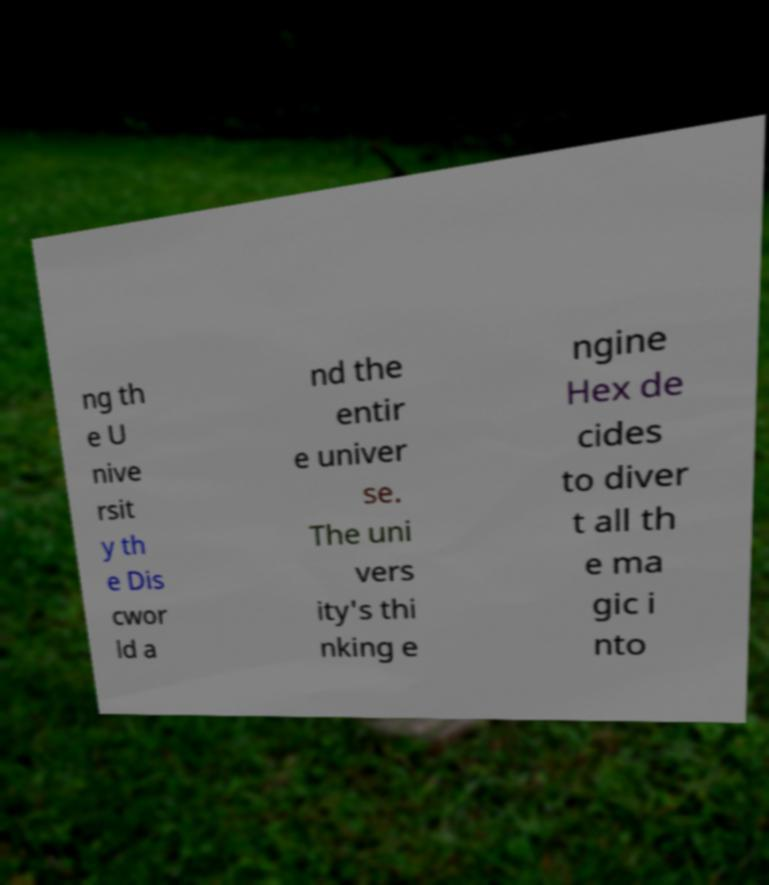Can you read and provide the text displayed in the image?This photo seems to have some interesting text. Can you extract and type it out for me? ng th e U nive rsit y th e Dis cwor ld a nd the entir e univer se. The uni vers ity's thi nking e ngine Hex de cides to diver t all th e ma gic i nto 